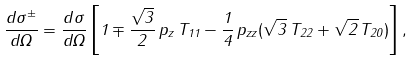Convert formula to latex. <formula><loc_0><loc_0><loc_500><loc_500>\frac { d \sigma ^ { \pm } } { d \Omega } = \frac { d \sigma } { d \Omega } \left [ 1 \mp \frac { \sqrt { 3 } } { 2 } \, p _ { z } \, T _ { 1 1 } - \frac { 1 } { 4 } \, p _ { z z } ( \sqrt { 3 } \, T _ { 2 2 } + \sqrt { 2 } \, T _ { 2 0 } ) \right ] ,</formula> 